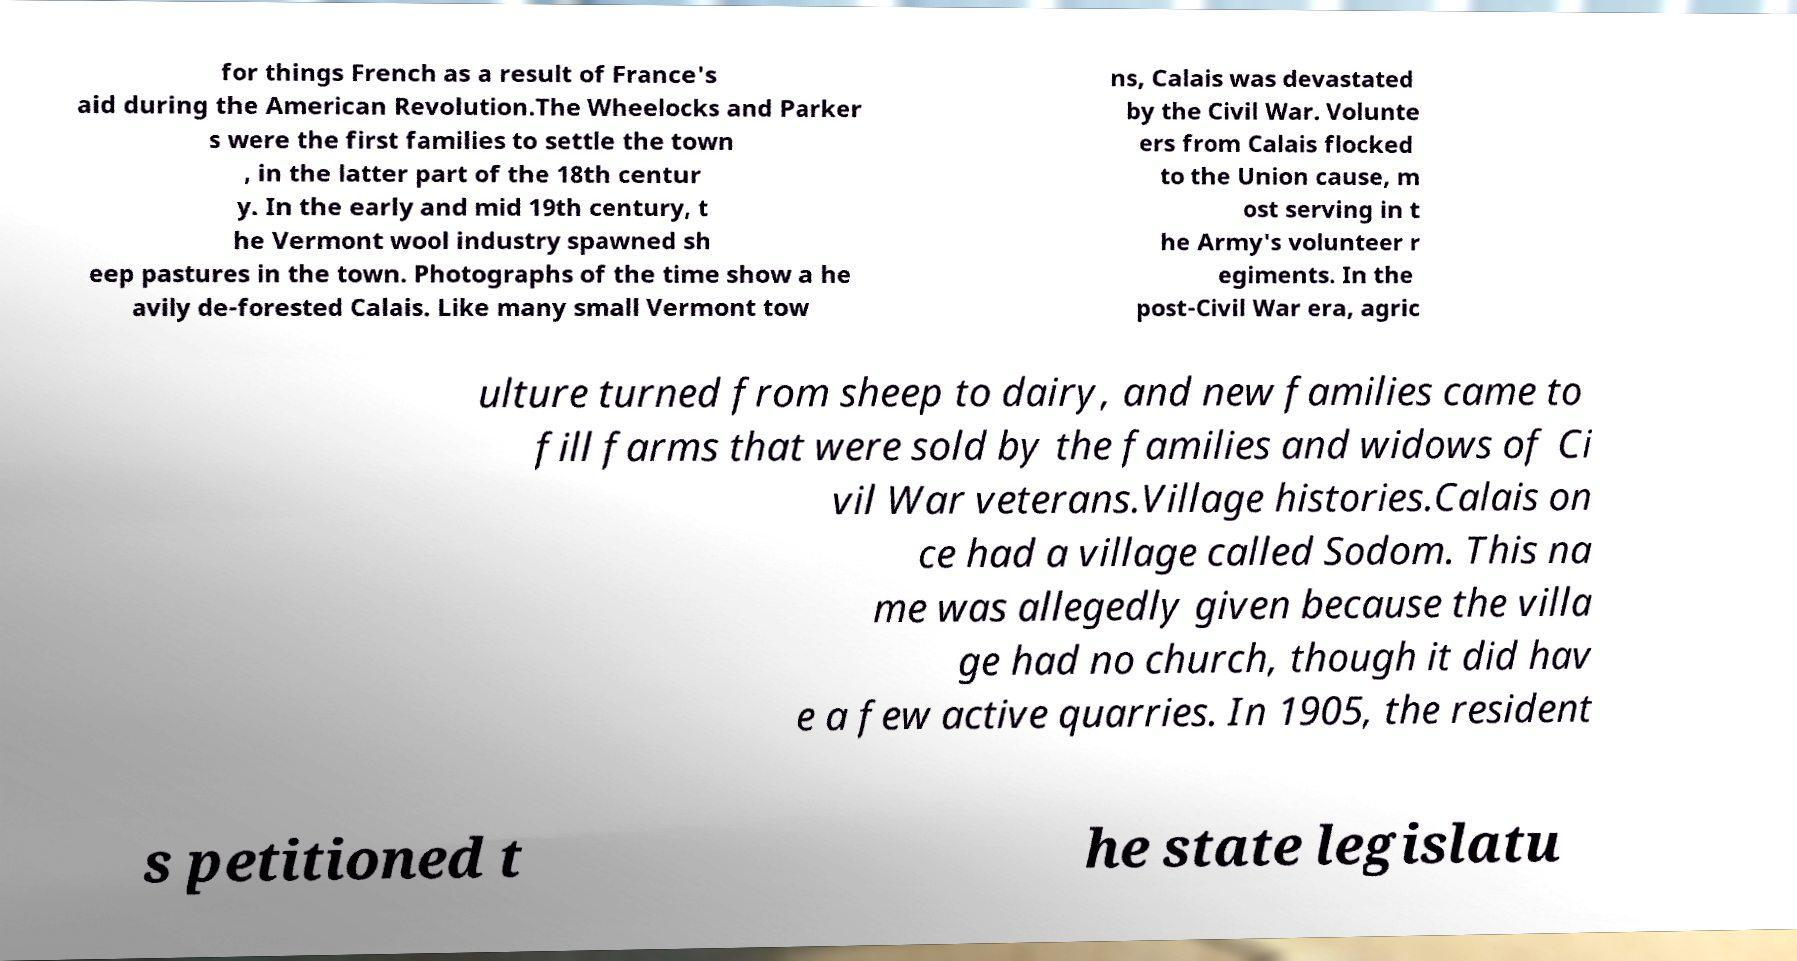What messages or text are displayed in this image? I need them in a readable, typed format. for things French as a result of France's aid during the American Revolution.The Wheelocks and Parker s were the first families to settle the town , in the latter part of the 18th centur y. In the early and mid 19th century, t he Vermont wool industry spawned sh eep pastures in the town. Photographs of the time show a he avily de-forested Calais. Like many small Vermont tow ns, Calais was devastated by the Civil War. Volunte ers from Calais flocked to the Union cause, m ost serving in t he Army's volunteer r egiments. In the post-Civil War era, agric ulture turned from sheep to dairy, and new families came to fill farms that were sold by the families and widows of Ci vil War veterans.Village histories.Calais on ce had a village called Sodom. This na me was allegedly given because the villa ge had no church, though it did hav e a few active quarries. In 1905, the resident s petitioned t he state legislatu 